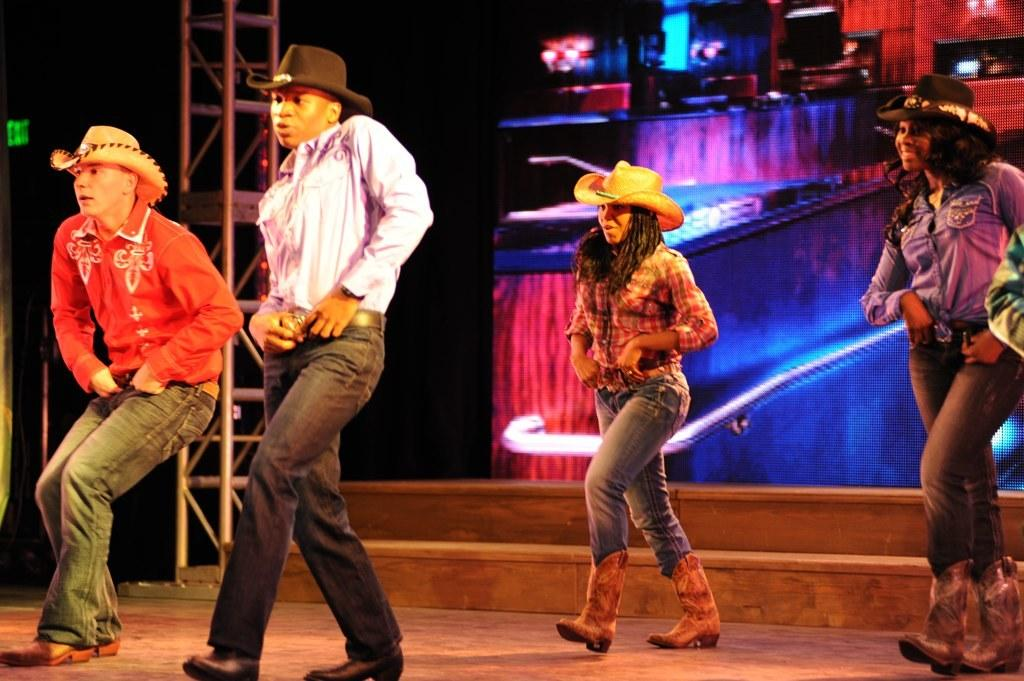What are the people in the image doing? There are people dancing in the center of the image. What can be seen in the background of the image? There is a screen in the background of the image. What is on the left side of the image? There is a pole on the left side of the image. What type of basket is hanging from the pole in the image? There is no basket hanging from the pole in the image; only a pole is present on the left side. 